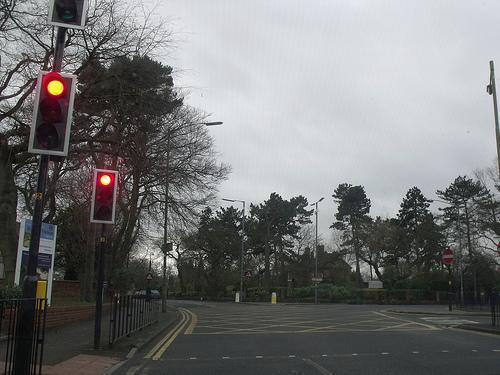How many traffic lights are on?
Give a very brief answer. 2. 